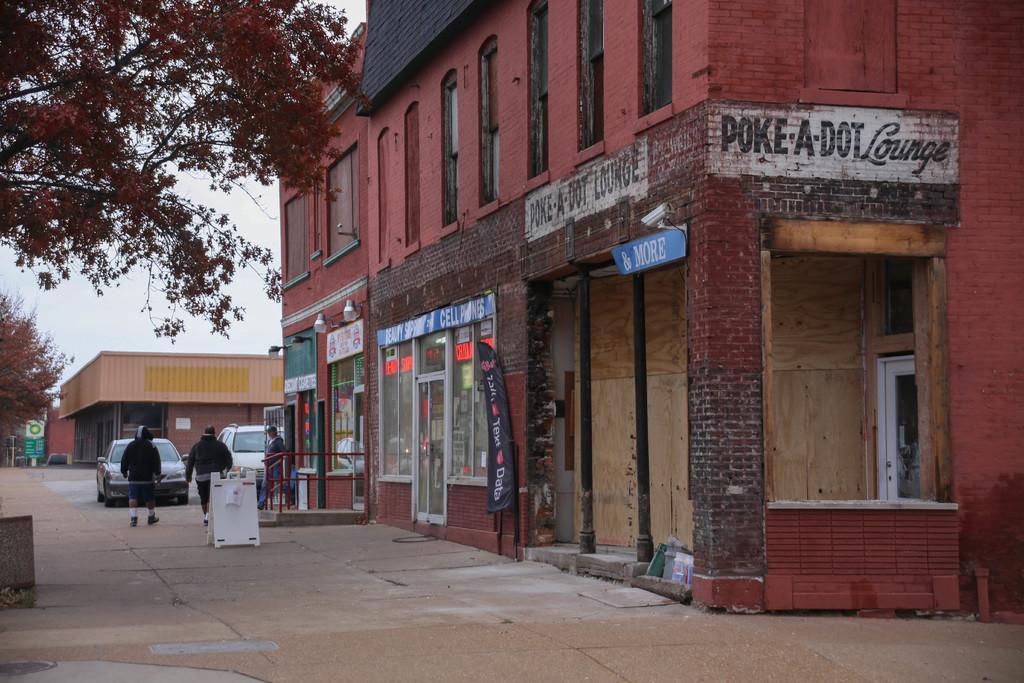Describe this image in one or two sentences. In this image we can see the building on the right side. Here we can see the windows. Here we can see three persons walking on the road. Here we can see two cars. Here we can see the trees on the left side. In the background, we can see the shed housing. 